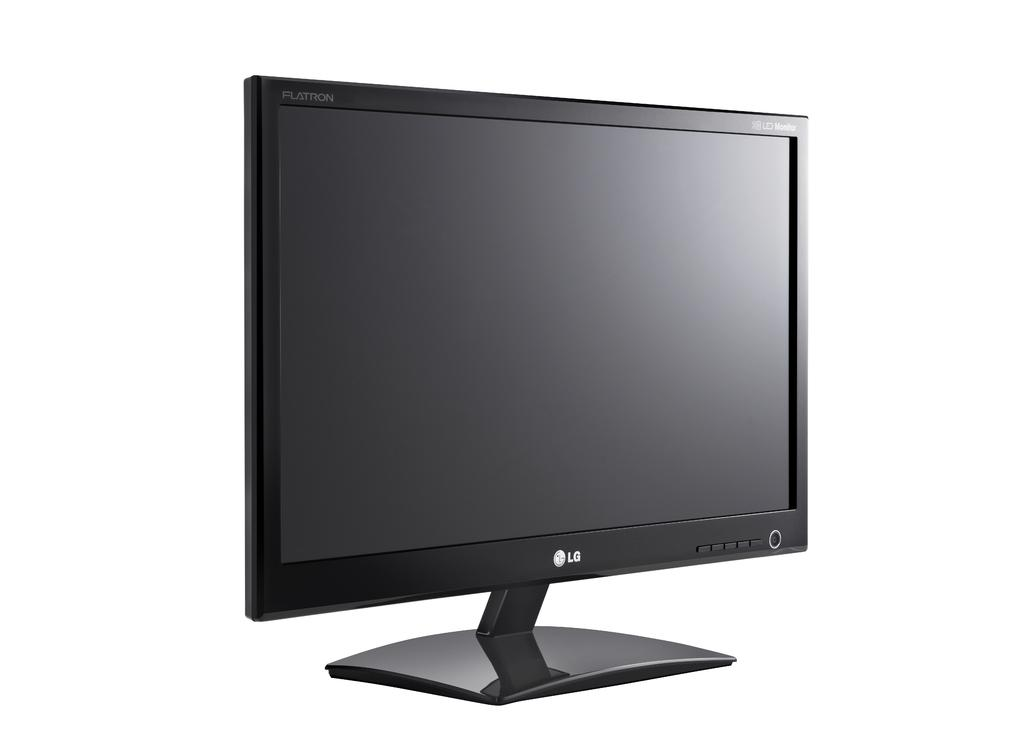<image>
Offer a succinct explanation of the picture presented. The dark monitor is from the brand LG 